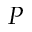Convert formula to latex. <formula><loc_0><loc_0><loc_500><loc_500>P</formula> 